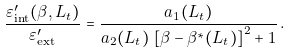Convert formula to latex. <formula><loc_0><loc_0><loc_500><loc_500>\frac { \varepsilon ^ { \prime } _ { \text {int} } ( \beta , L _ { t } ) } { \varepsilon ^ { \prime } _ { \text {ext} } } = \frac { a _ { 1 } ( L _ { t } ) } { a _ { 2 } ( L _ { t } ) \, \left [ \beta - \beta ^ { * } ( L _ { t } ) \right ] ^ { 2 } + 1 } \, .</formula> 